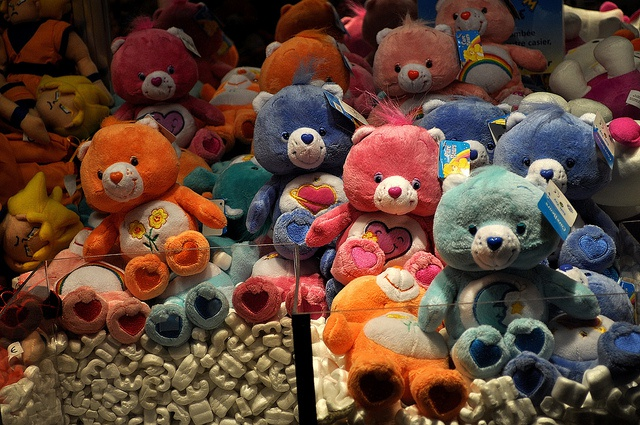Describe the objects in this image and their specific colors. I can see teddy bear in black, maroon, and gray tones, teddy bear in black, gray, darkgray, and lightblue tones, teddy bear in black, maroon, brown, and red tones, teddy bear in black, salmon, brown, and maroon tones, and teddy bear in black, red, orange, and maroon tones in this image. 